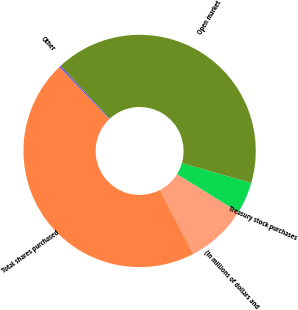Convert chart to OTSL. <chart><loc_0><loc_0><loc_500><loc_500><pie_chart><fcel>(In millions of dollars and<fcel>Treasury stock purchases<fcel>Open market<fcel>Other<fcel>Total shares purchased<nl><fcel>8.53%<fcel>4.39%<fcel>41.34%<fcel>0.26%<fcel>45.48%<nl></chart> 